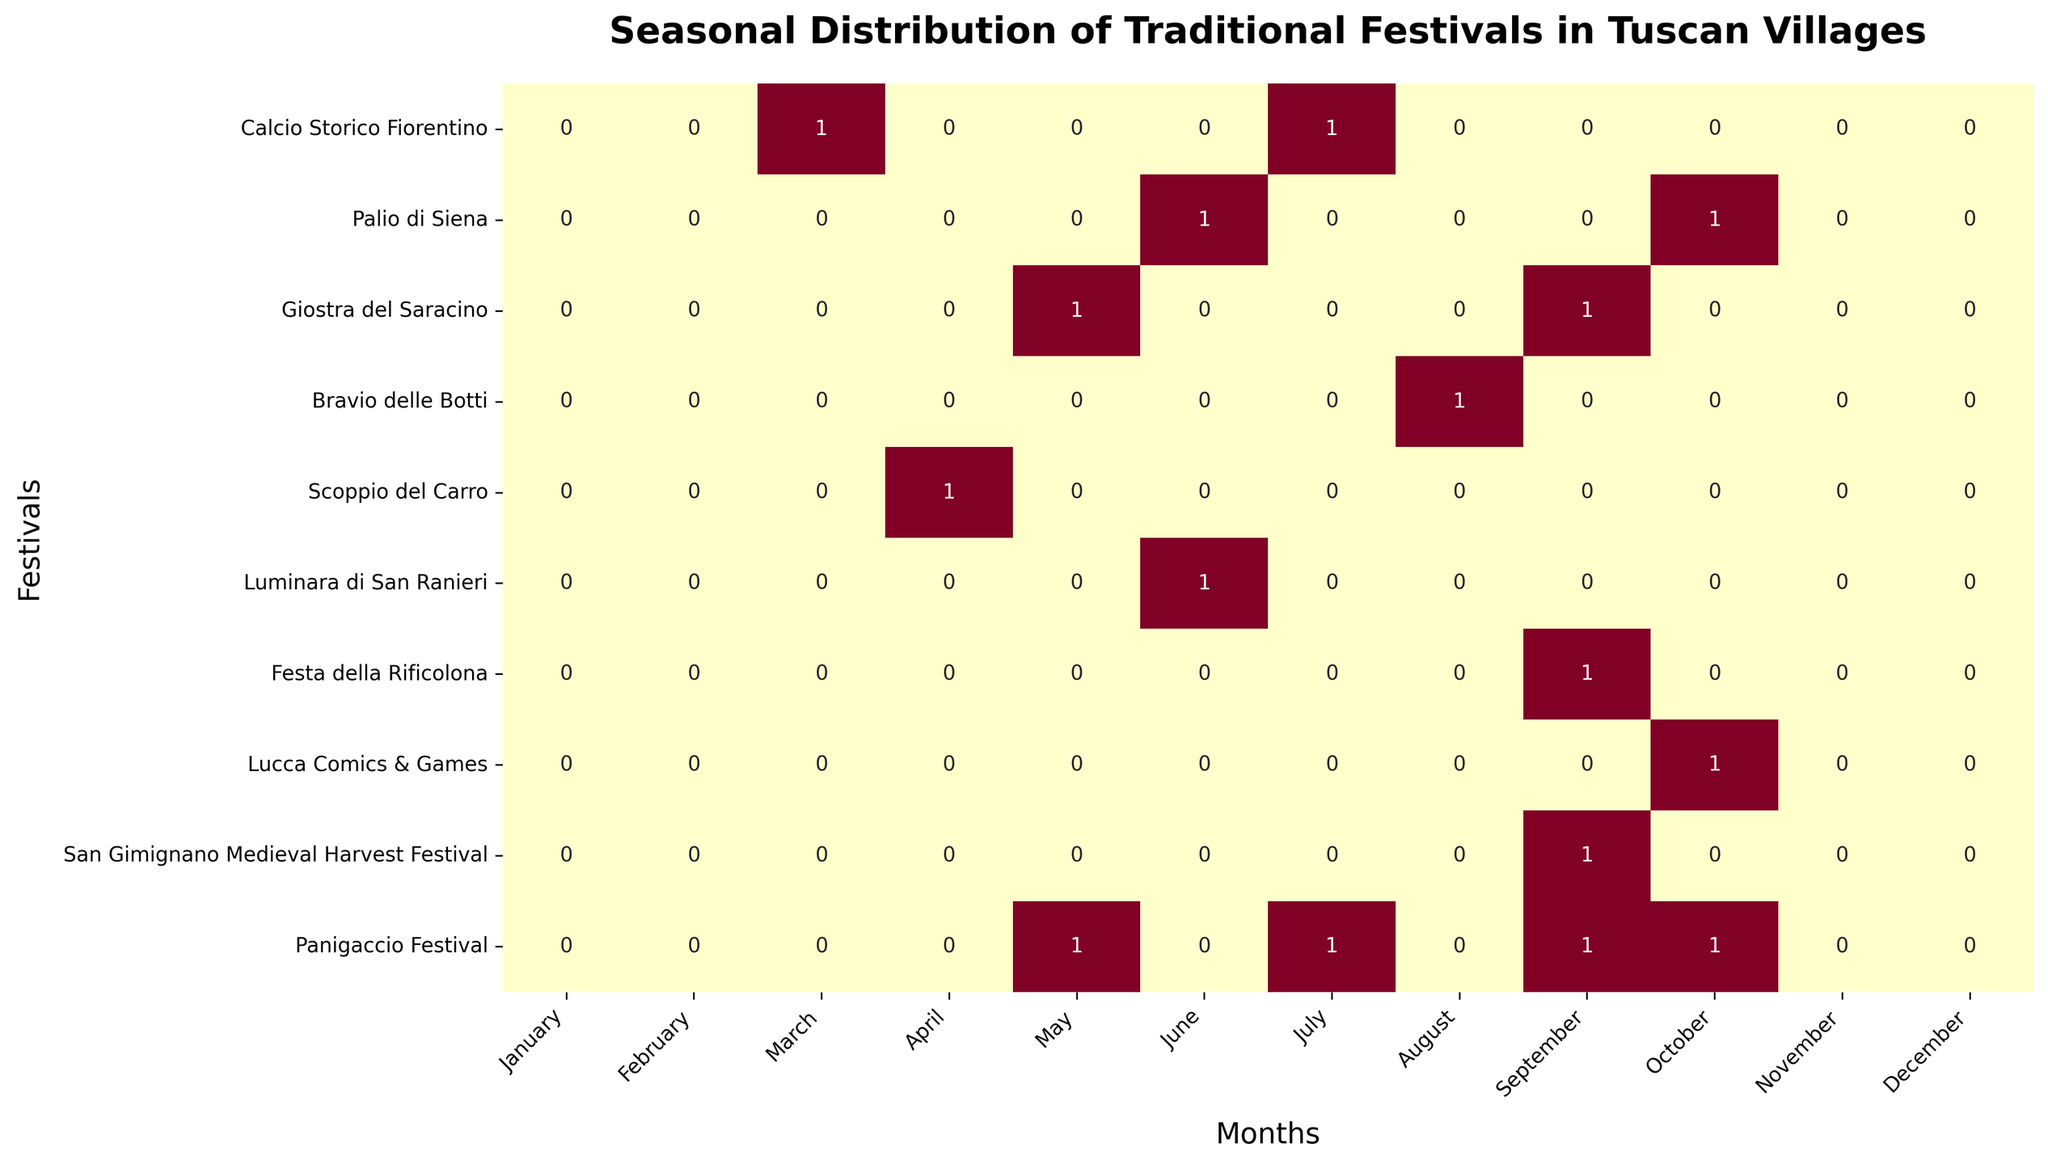Which month has the highest number of festivals? Check the heatmap for the month with the most entries greater than 0. It appears that September has 4 festivals indicated.
Answer: September How many festivals are held in June? Identify the row for June and count the number of entries that equal 1. There are 3 festivals in June.
Answer: 3 In which months is the "Palio di Siena" held? Locate the row corresponding to "Palio di Siena" and identify the months where the value is 1. It is held in June and October.
Answer: June, October Which festival is held during March? Find the column for March and look for the festival with a value of 1. The "Calcio Storico Fiorentino" is held in March.
Answer: Calcio Storico Fiorentino Compare the number of festivals in the first half of the year (January to June) versus the second half (July to December). Which half has more festivals? Count the total number of 1s in the months January to June and compare it with the count of 1s from July to December. The first half of the year has 5 festivals, and the second half has 10 festivals.
Answer: Second half How many festivals are held in April and July combined? Find the festivals in April and add them with those in July. April has 1 festival and July has 2, so the total is 3.
Answer: 3 Which festival is only held in August? Look at the column for August and locate the festival that has a unique 1. The "Bravio delle Botti" is held only in August.
Answer: Bravio delle Botti Are there any festivals held in January or February? Look at the columns for January and February; there are no entries with a value of 1 in either month.
Answer: No Does any festival occur in both May and September? Check for any festivals that have 1 for both May and September. The "Panigaccio Festival" occurs in both months.
Answer: Panigaccio Festival Which month has the least number of festivals? Identify the month column with the fewest entries of 1. January and February both have zero festivals, making them the least.
Answer: January, February 